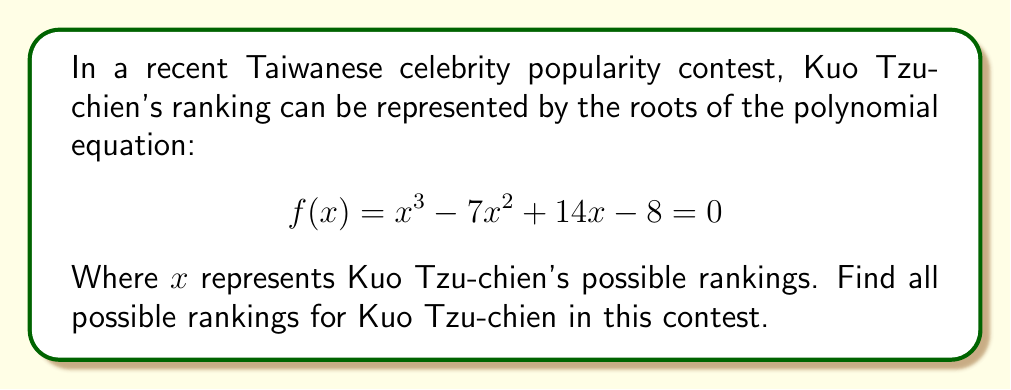Could you help me with this problem? To find the roots of the polynomial equation, we need to factor the equation or use algebraic methods. Let's approach this step-by-step:

1) First, let's check if there's a rational root. We can use the rational root theorem. The possible rational roots are the factors of the constant term (8): ±1, ±2, ±4, ±8.

2) Testing these values, we find that $f(1) = 0$. So, $(x-1)$ is a factor.

3) We can use polynomial long division to divide $f(x)$ by $(x-1)$:

   $$\frac{x^3 - 7x^2 + 14x - 8}{x-1} = x^2 - 6x + 8$$

4) So, $f(x) = (x-1)(x^2 - 6x + 8)$

5) Now we need to factor $x^2 - 6x + 8$. We can use the quadratic formula:

   $$x = \frac{-b \pm \sqrt{b^2 - 4ac}}{2a}$$

   Where $a=1$, $b=-6$, and $c=8$

6) Plugging in these values:

   $$x = \frac{6 \pm \sqrt{36 - 32}}{2} = \frac{6 \pm 2}{2}$$

7) This gives us two more roots:

   $$x = 4$$ or $$x = 2$$

Therefore, the roots of the equation are 1, 2, and 4.
Answer: 1, 2, 4 